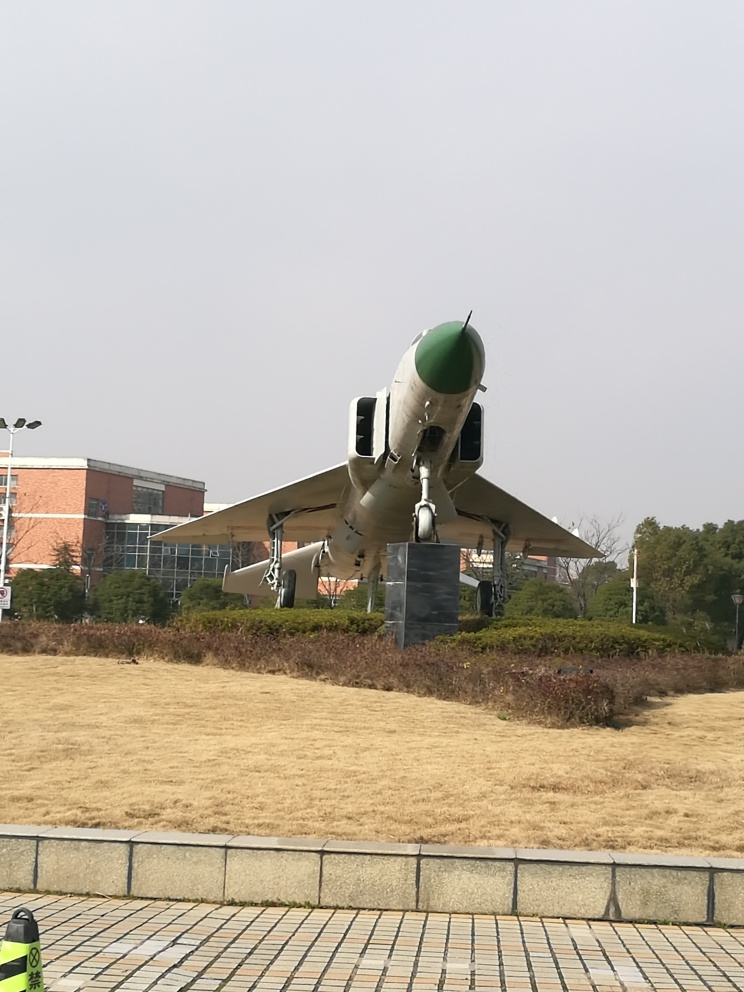Can you describe the kind of aircraft shown in the image? The aircraft in the image appears to be a military fighter jet, notable for its distinctive nose cone, jet engines on either side of the fuselage, and swept wings. The design suggests a focus on speed and maneuverability, typical of combat aircraft. The exact model is difficult to determine without closer inspection or additional knowledge about its distinguishing features. 